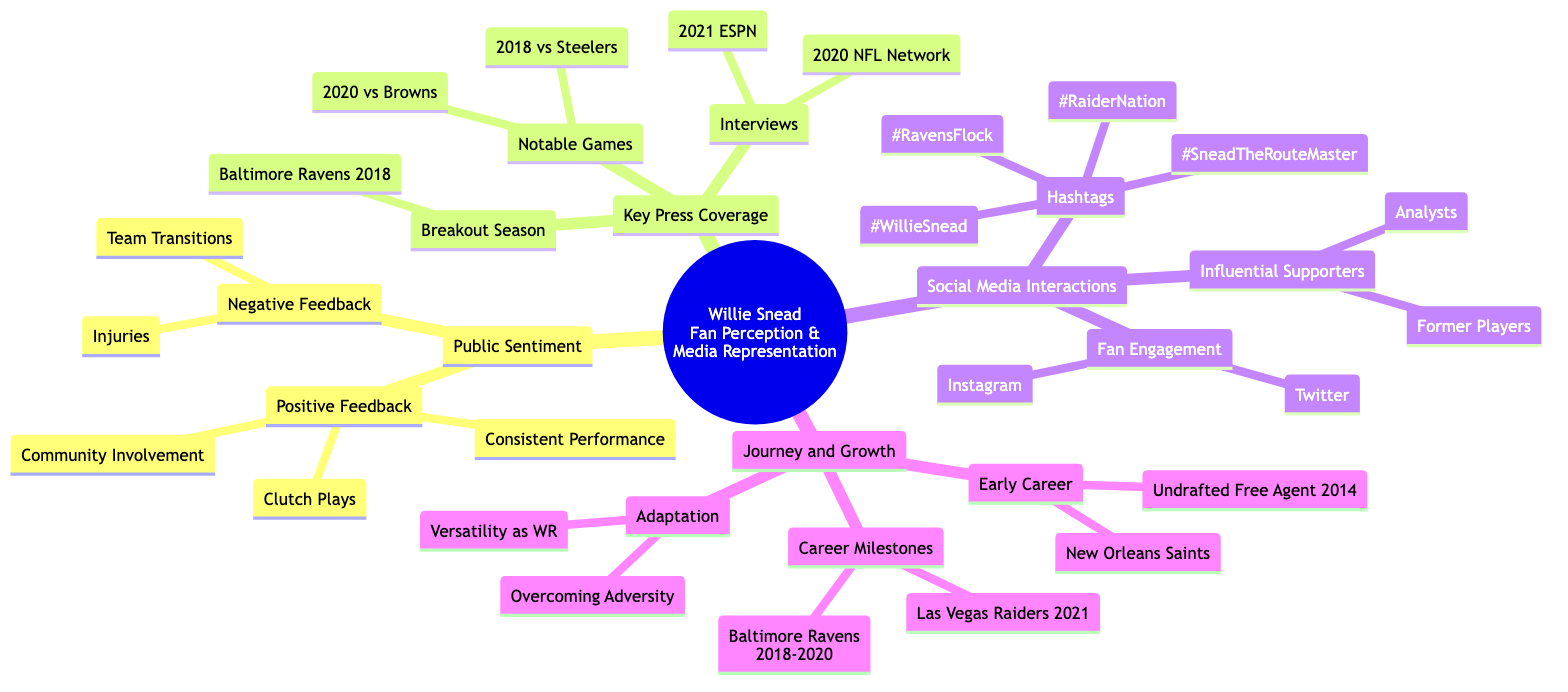What are three examples of positive feedback regarding Willie Snead? According to the diagram, the section on positive feedback outlines three specific examples: Consistent Performance, Clutch Plays, and Community Involvement.
Answer: Consistent Performance, Clutch Plays, Community Involvement What year did Willie Snead have his breakout season? The diagram identifies the specific event of his breakout season as occurring with the Baltimore Ravens in 2018.
Answer: Baltimore Ravens 2018 How many notable games are listed in the Key Press Coverage section? The diagram provides a count of the notable games listed under the Key Press Coverage; there are two games mentioned: 2018 vs Steelers and 2020 vs Browns.
Answer: 2 Which media outlet conducted an interview with Willie Snead in 2021? The diagram lists the interviews conducted with Willie Snead and specifies that one interview was conducted by ESPN in 2021.
Answer: ESPN What are two social media platforms mentioned for fan engagement? The diagram highlights two platforms where fan engagement occurs: Twitter and Instagram are directly mentioned under the Social Media Interactions section.
Answer: Twitter, Instagram Which two teams did Willie Snead play for in his early career? The diagram provides specific mentions under the Journey and Growth section, noting that Willie Snead started as an Undrafted Free Agent in 2014 and later played for the New Orleans Saints.
Answer: Undrafted Free Agent 2014, New Orleans Saints What is a key theme in Willie Snead's journey and growth? The diagram specifies themes under Journey and Growth, where Adaptation is a highlighted theme, particularly focusing on Overcoming Adversity and Versatility as a WR.
Answer: Adaptation What hashtag reflects the fanbase of the Las Vegas Raiders? The diagram showcases different hashtags used in social media interactions, and #RaiderNation clearly reflects the fanbase of the Las Vegas Raiders.
Answer: #RaiderNation 